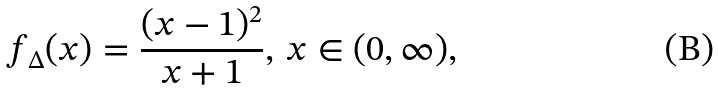<formula> <loc_0><loc_0><loc_500><loc_500>f _ { \Delta } ( x ) = \frac { ( x - 1 ) ^ { 2 } } { x + 1 } , \, x \in ( 0 , \infty ) ,</formula> 